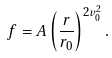Convert formula to latex. <formula><loc_0><loc_0><loc_500><loc_500>f = A \left ( \frac { r } { r _ { 0 } } \right ) ^ { 2 v _ { 0 } ^ { 2 } } .</formula> 